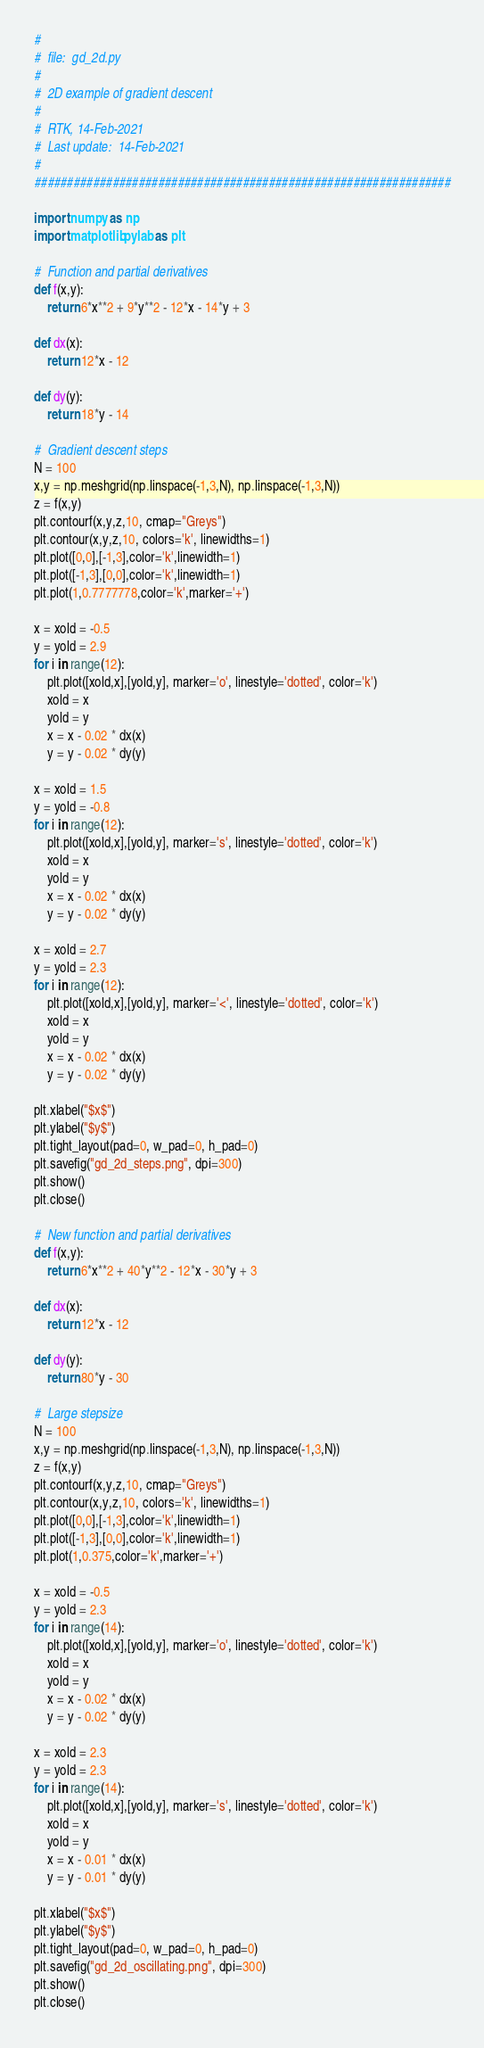Convert code to text. <code><loc_0><loc_0><loc_500><loc_500><_Python_>#
#  file:  gd_2d.py
#
#  2D example of gradient descent
#
#  RTK, 14-Feb-2021
#  Last update:  14-Feb-2021
#
################################################################

import numpy as np
import matplotlib.pylab as plt

#  Function and partial derivatives
def f(x,y):
    return 6*x**2 + 9*y**2 - 12*x - 14*y + 3

def dx(x):
    return 12*x - 12

def dy(y):
    return 18*y - 14

#  Gradient descent steps
N = 100
x,y = np.meshgrid(np.linspace(-1,3,N), np.linspace(-1,3,N))
z = f(x,y)
plt.contourf(x,y,z,10, cmap="Greys")
plt.contour(x,y,z,10, colors='k', linewidths=1)
plt.plot([0,0],[-1,3],color='k',linewidth=1)
plt.plot([-1,3],[0,0],color='k',linewidth=1)
plt.plot(1,0.7777778,color='k',marker='+')

x = xold = -0.5
y = yold = 2.9
for i in range(12):
    plt.plot([xold,x],[yold,y], marker='o', linestyle='dotted', color='k')
    xold = x
    yold = y
    x = x - 0.02 * dx(x)
    y = y - 0.02 * dy(y)

x = xold = 1.5
y = yold = -0.8
for i in range(12):
    plt.plot([xold,x],[yold,y], marker='s', linestyle='dotted', color='k')
    xold = x
    yold = y
    x = x - 0.02 * dx(x)
    y = y - 0.02 * dy(y)

x = xold = 2.7
y = yold = 2.3
for i in range(12):
    plt.plot([xold,x],[yold,y], marker='<', linestyle='dotted', color='k')
    xold = x
    yold = y
    x = x - 0.02 * dx(x)
    y = y - 0.02 * dy(y)

plt.xlabel("$x$")
plt.ylabel("$y$")
plt.tight_layout(pad=0, w_pad=0, h_pad=0)
plt.savefig("gd_2d_steps.png", dpi=300)
plt.show()
plt.close()

#  New function and partial derivatives
def f(x,y):
    return 6*x**2 + 40*y**2 - 12*x - 30*y + 3

def dx(x):
    return 12*x - 12

def dy(y):
    return 80*y - 30

#  Large stepsize
N = 100
x,y = np.meshgrid(np.linspace(-1,3,N), np.linspace(-1,3,N))
z = f(x,y)
plt.contourf(x,y,z,10, cmap="Greys")
plt.contour(x,y,z,10, colors='k', linewidths=1)
plt.plot([0,0],[-1,3],color='k',linewidth=1)
plt.plot([-1,3],[0,0],color='k',linewidth=1)
plt.plot(1,0.375,color='k',marker='+')

x = xold = -0.5
y = yold = 2.3
for i in range(14):
    plt.plot([xold,x],[yold,y], marker='o', linestyle='dotted', color='k')
    xold = x
    yold = y
    x = x - 0.02 * dx(x)
    y = y - 0.02 * dy(y)

x = xold = 2.3
y = yold = 2.3
for i in range(14):
    plt.plot([xold,x],[yold,y], marker='s', linestyle='dotted', color='k')
    xold = x
    yold = y
    x = x - 0.01 * dx(x)
    y = y - 0.01 * dy(y)

plt.xlabel("$x$")
plt.ylabel("$y$")
plt.tight_layout(pad=0, w_pad=0, h_pad=0)
plt.savefig("gd_2d_oscillating.png", dpi=300)
plt.show()
plt.close()

</code> 